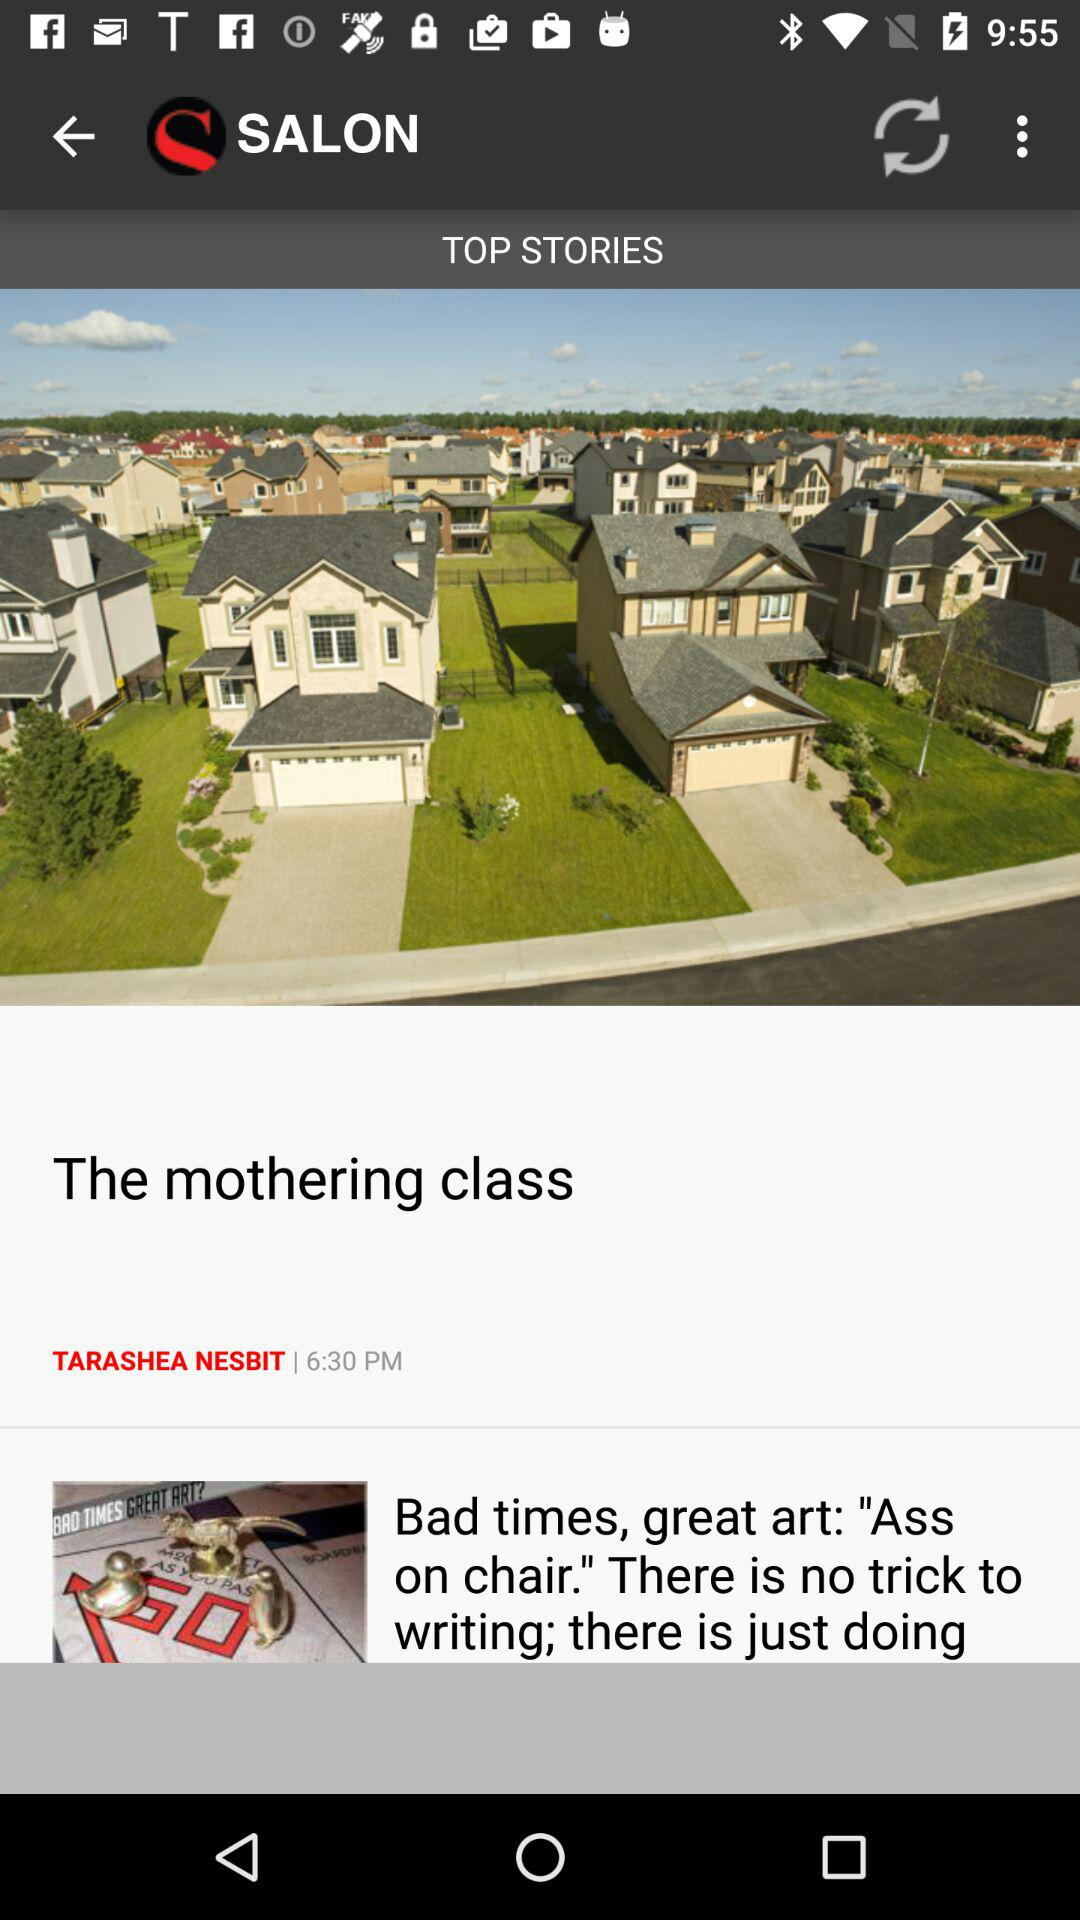Who is the author of "The mothering class"? The author is Tarashea Nesbit. 